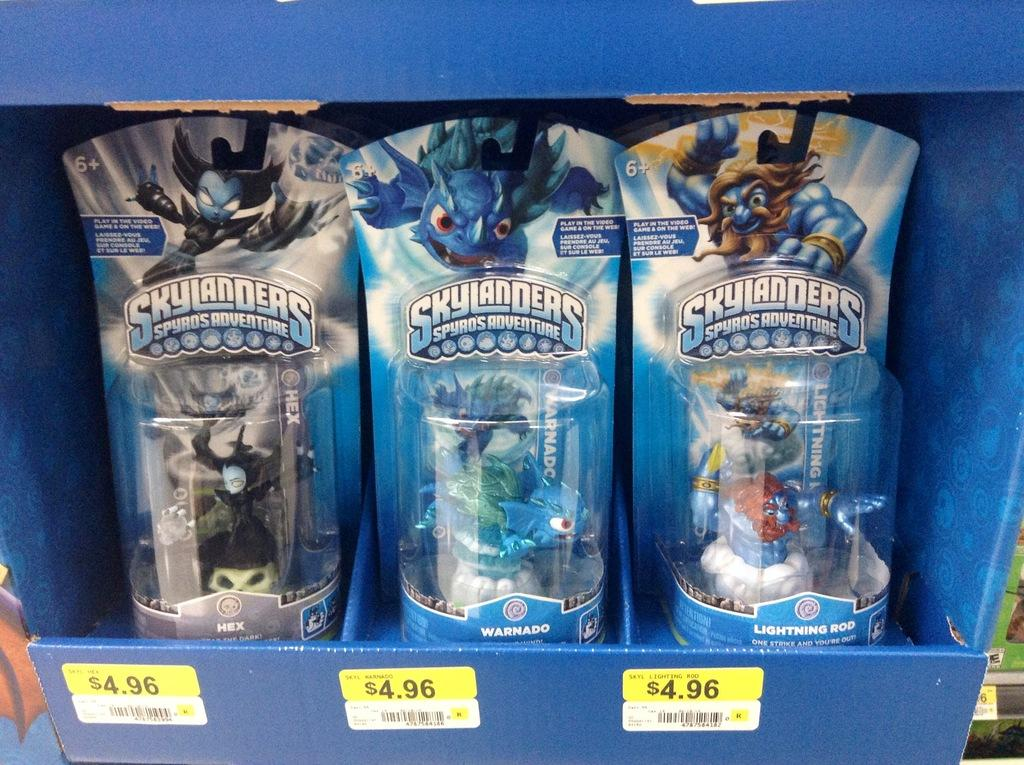What is the color of the box in the image? The box in the image is blue. What is inside the box? There are three toys in the box. Are there any additional details about the box? Yes, there are price stickers on the box. What type of bed is visible in the image? There is no bed present in the image; it features a blue color box with three toys and price stickers. What is the message of the good-bye note on the box? There is no good-bye note present on the box; it only has price stickers. 